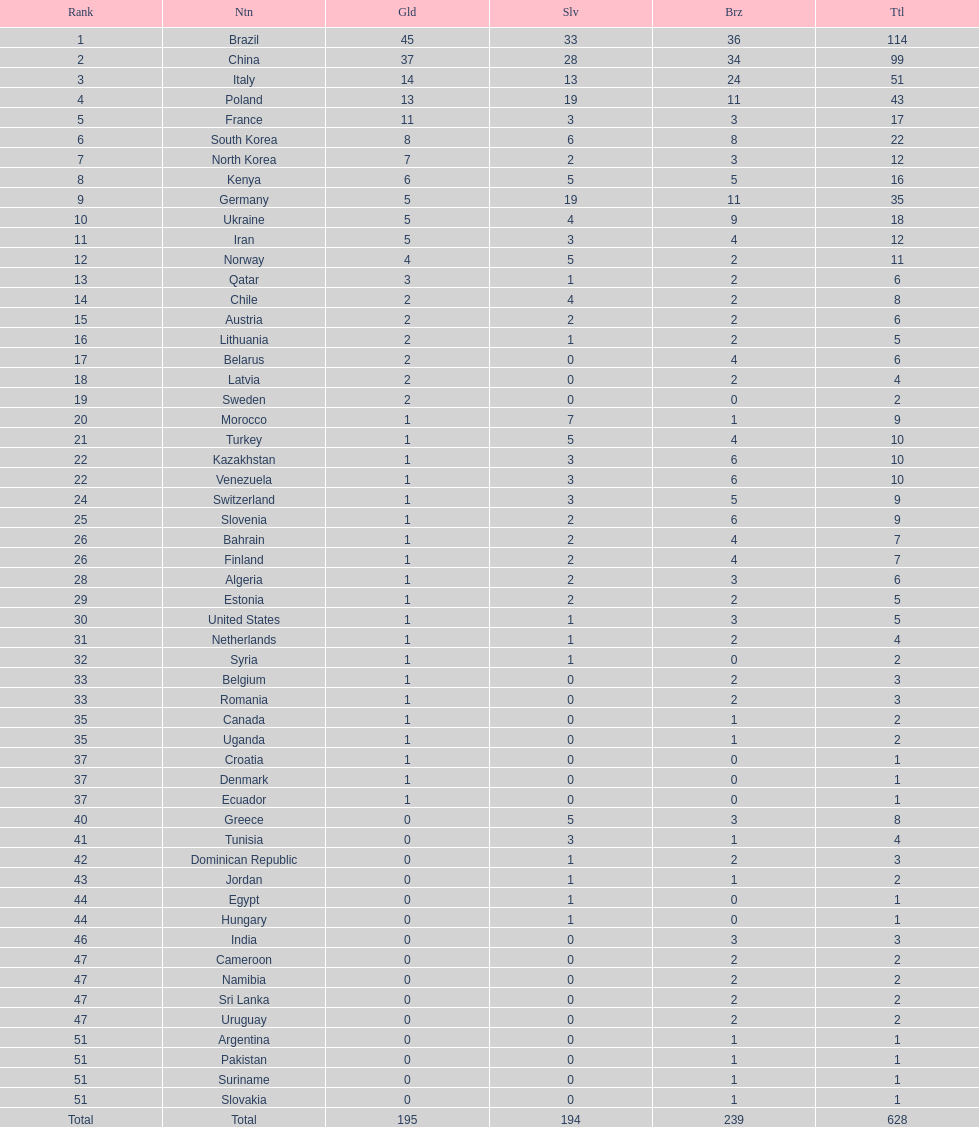What is the total number of medals between south korea, north korea, sweden, and brazil? 150. 